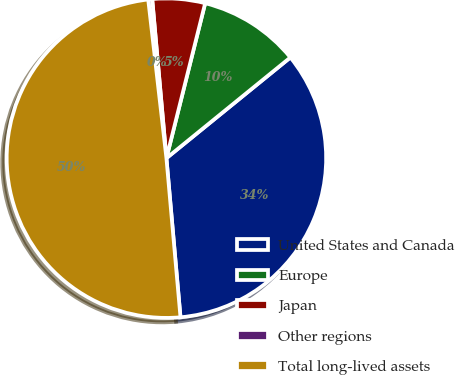<chart> <loc_0><loc_0><loc_500><loc_500><pie_chart><fcel>United States and Canada<fcel>Europe<fcel>Japan<fcel>Other regions<fcel>Total long-lived assets<nl><fcel>34.46%<fcel>10.24%<fcel>5.32%<fcel>0.4%<fcel>49.59%<nl></chart> 